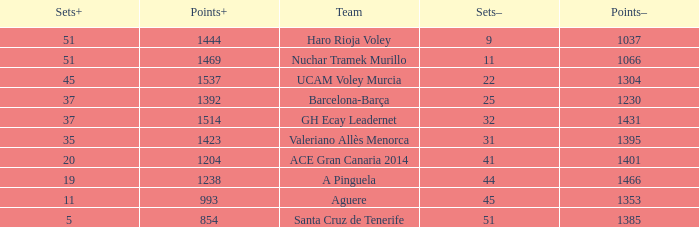Who is the team who had a Sets+ number smaller than 20, a Sets- number of 45, and a Points+ number smaller than 1238? Aguere. 